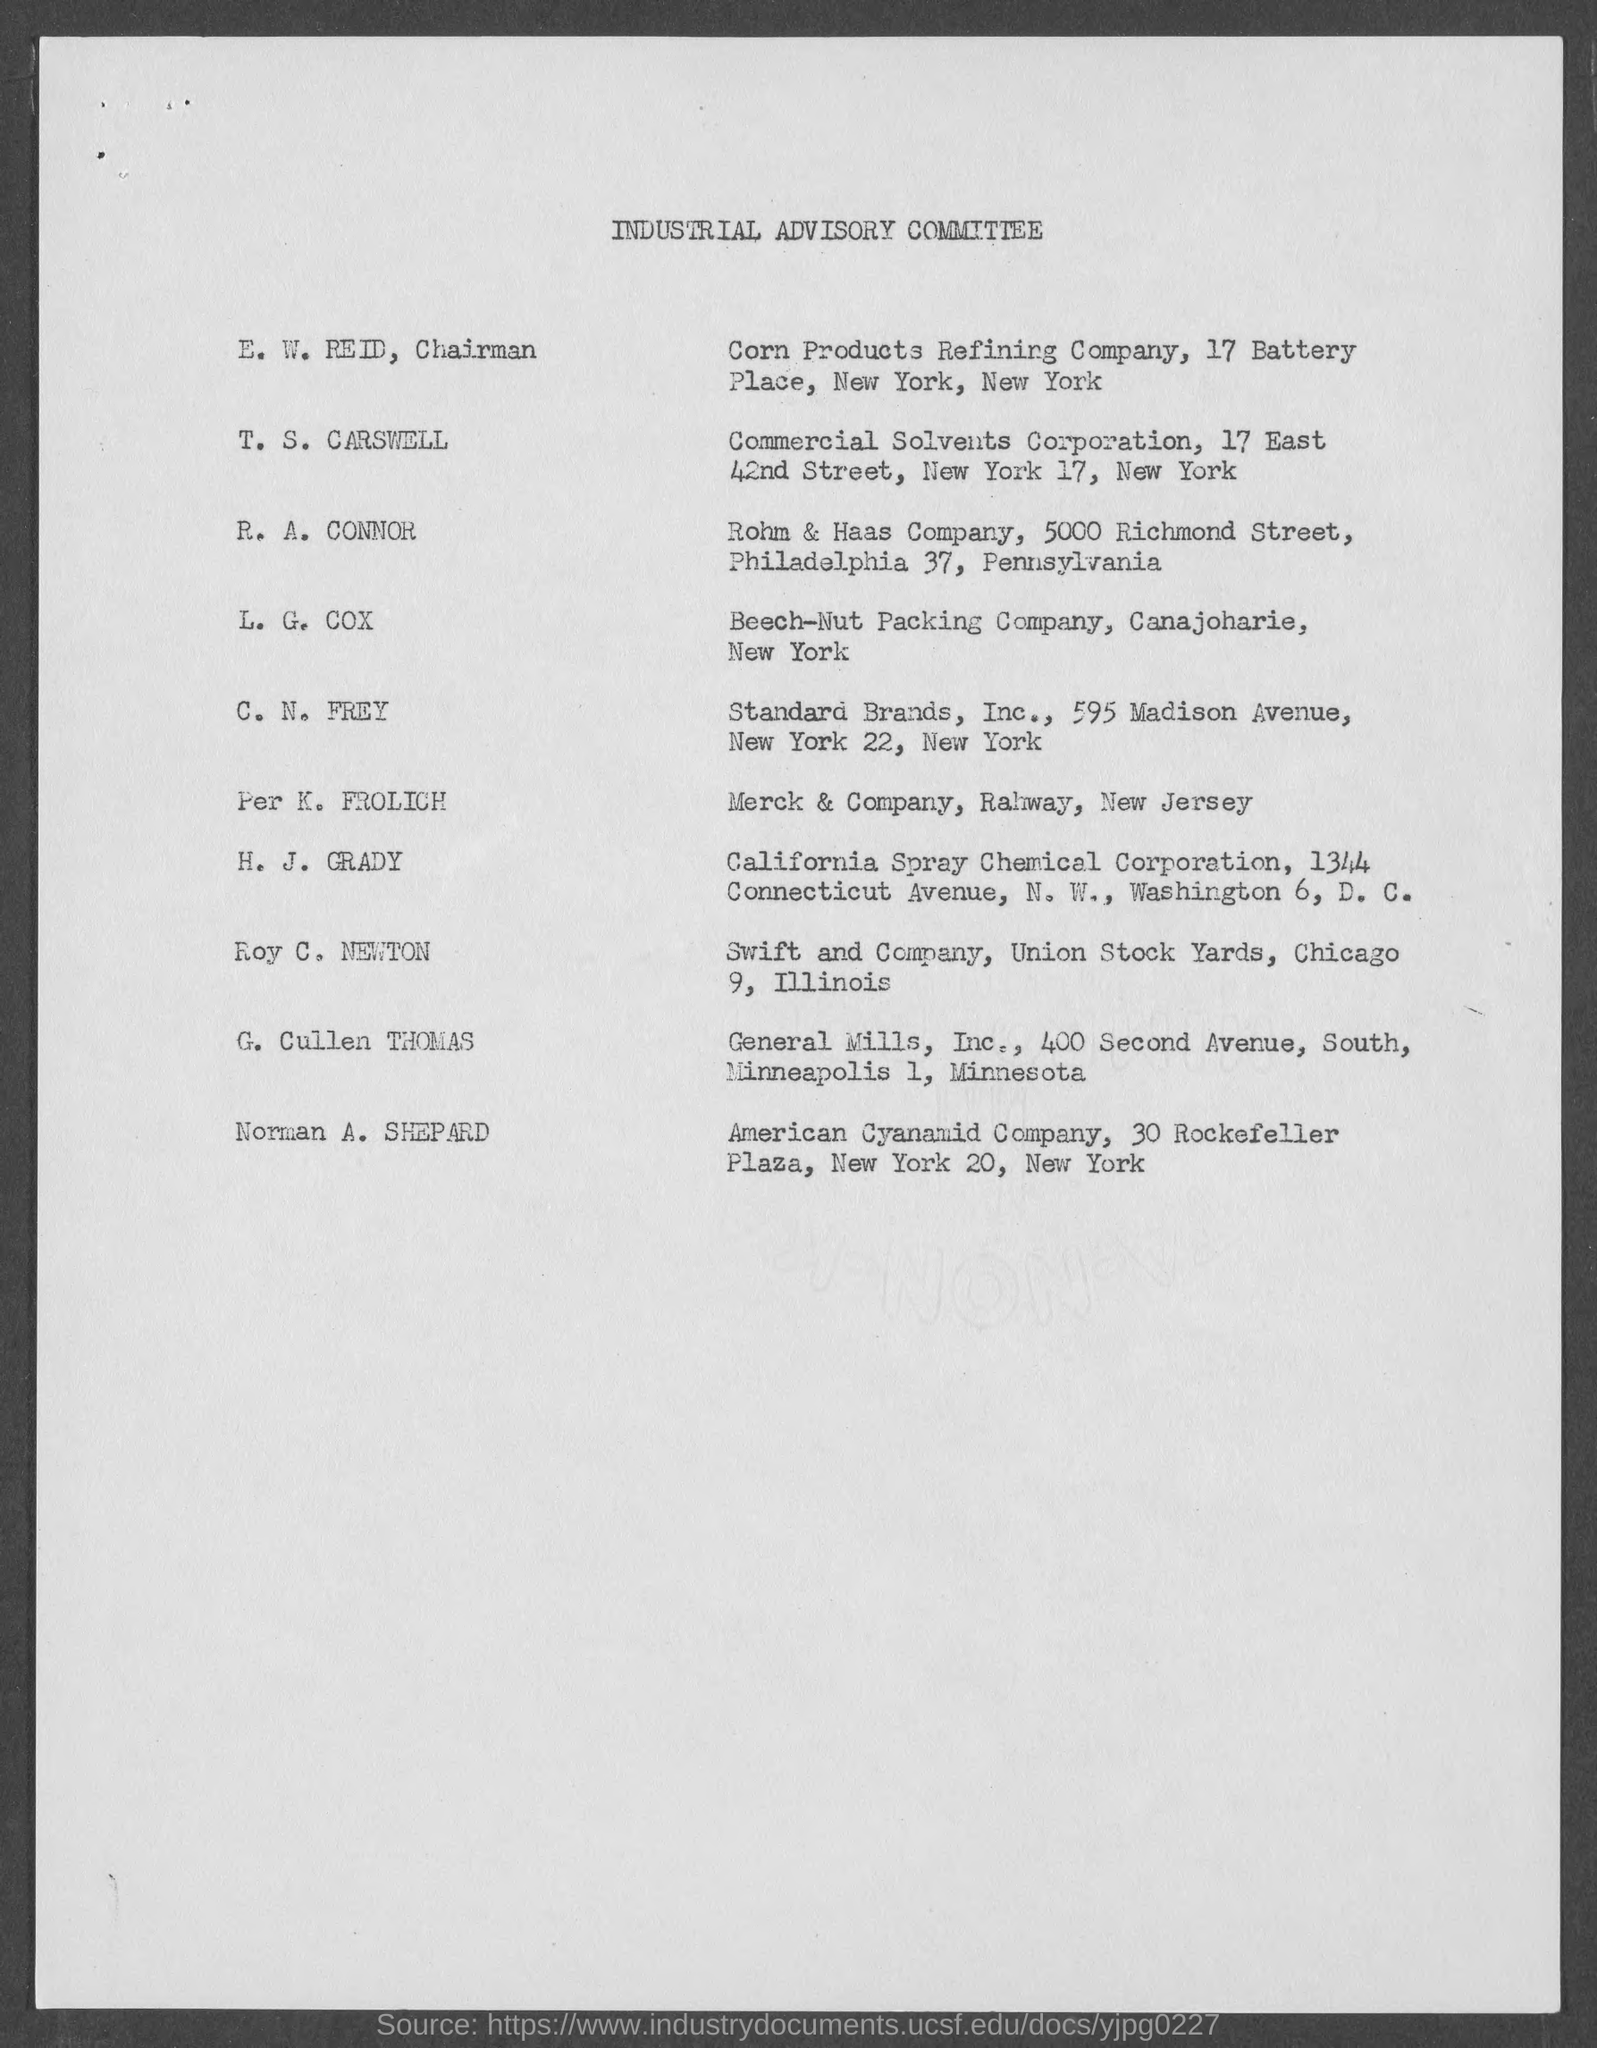What is the Title of the document?
Ensure brevity in your answer.  Industrial Advisory Committee. Who is the Chairman?
Offer a terse response. E. W. Reid. 